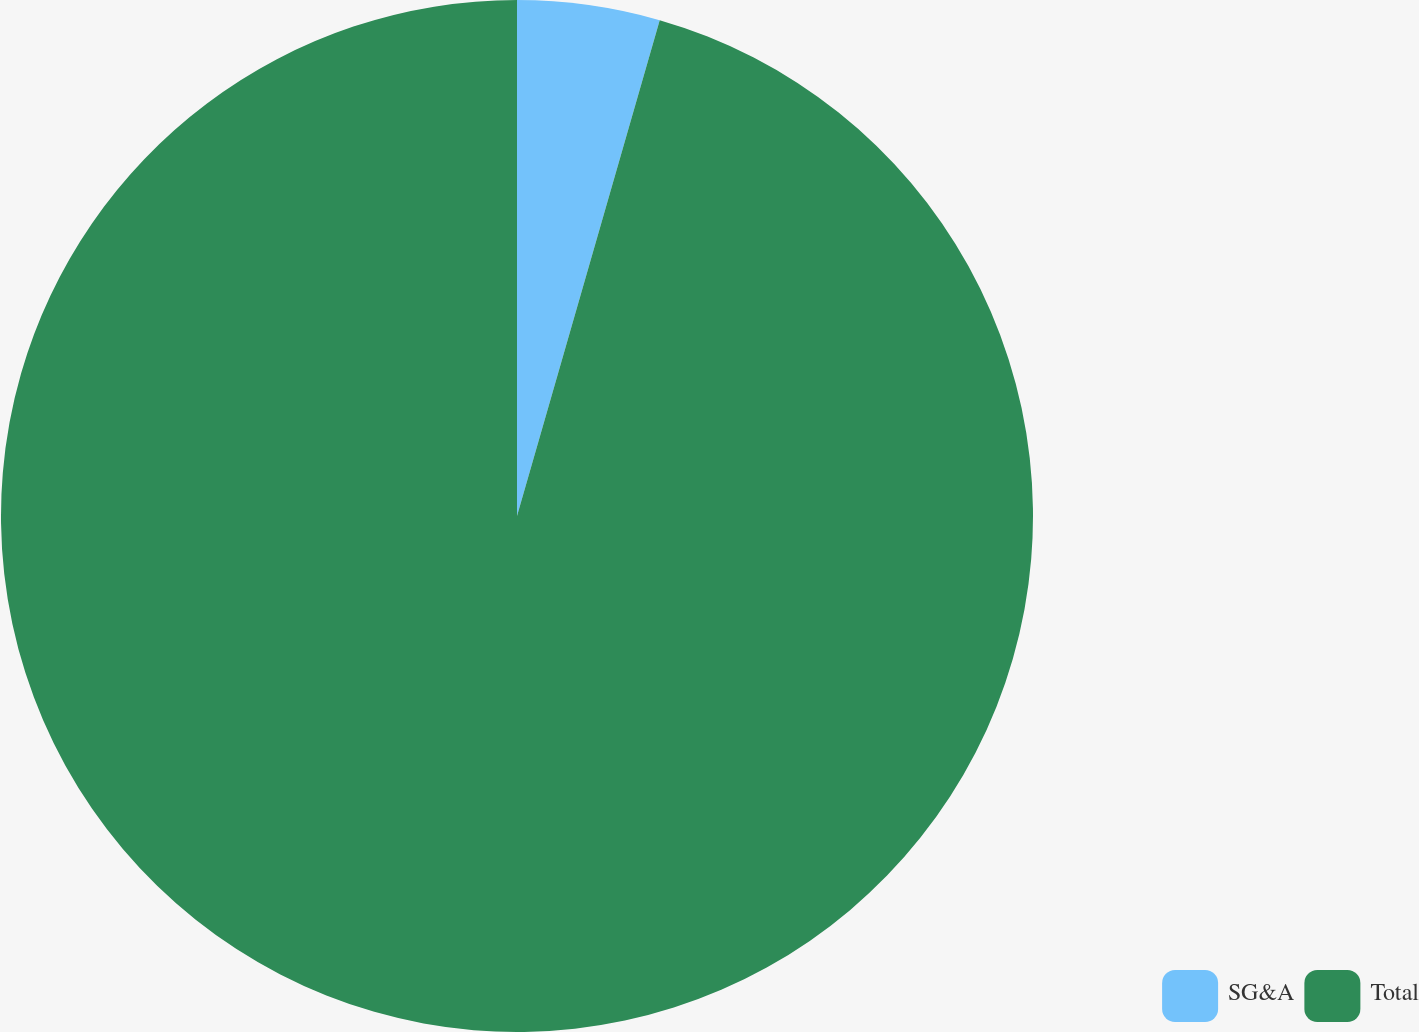Convert chart. <chart><loc_0><loc_0><loc_500><loc_500><pie_chart><fcel>SG&A<fcel>Total<nl><fcel>4.46%<fcel>95.54%<nl></chart> 